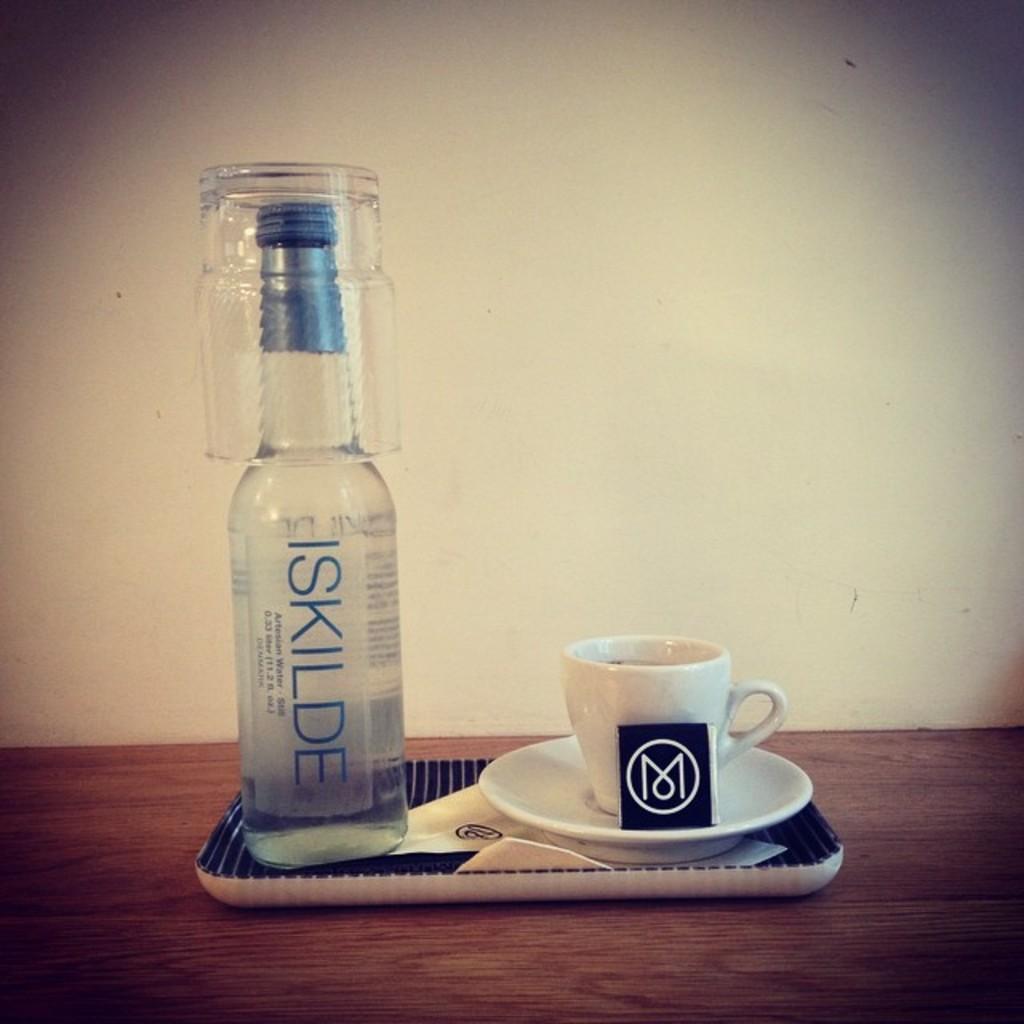What brand is shown on the bottle?
Offer a terse response. Iskilde. 